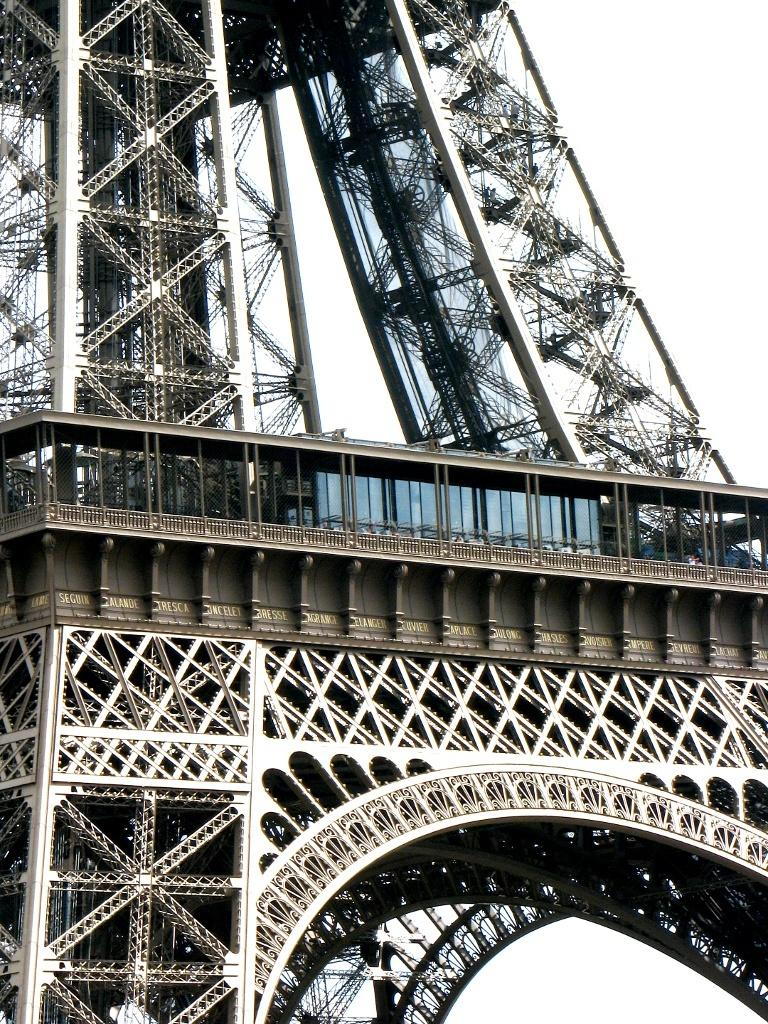What famous landmark is visible in the image? There is a part of the Eiffel Tower in the image. What can be seen in the background of the image? The sky is visible in the background of the image. What type of stem can be seen growing from the base of the Eiffel Tower in the image? There is no stem growing from the base of the Eiffel Tower in the image. What type of agreement is being signed by the people in the image? There are no people or agreements present in the image; it only features a part of the Eiffel Tower and the sky. 